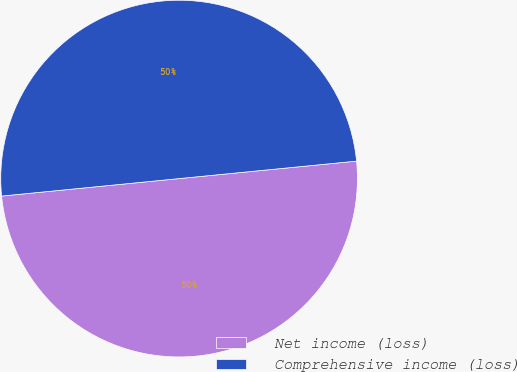<chart> <loc_0><loc_0><loc_500><loc_500><pie_chart><fcel>Net income (loss)<fcel>Comprehensive income (loss)<nl><fcel>50.0%<fcel>50.0%<nl></chart> 